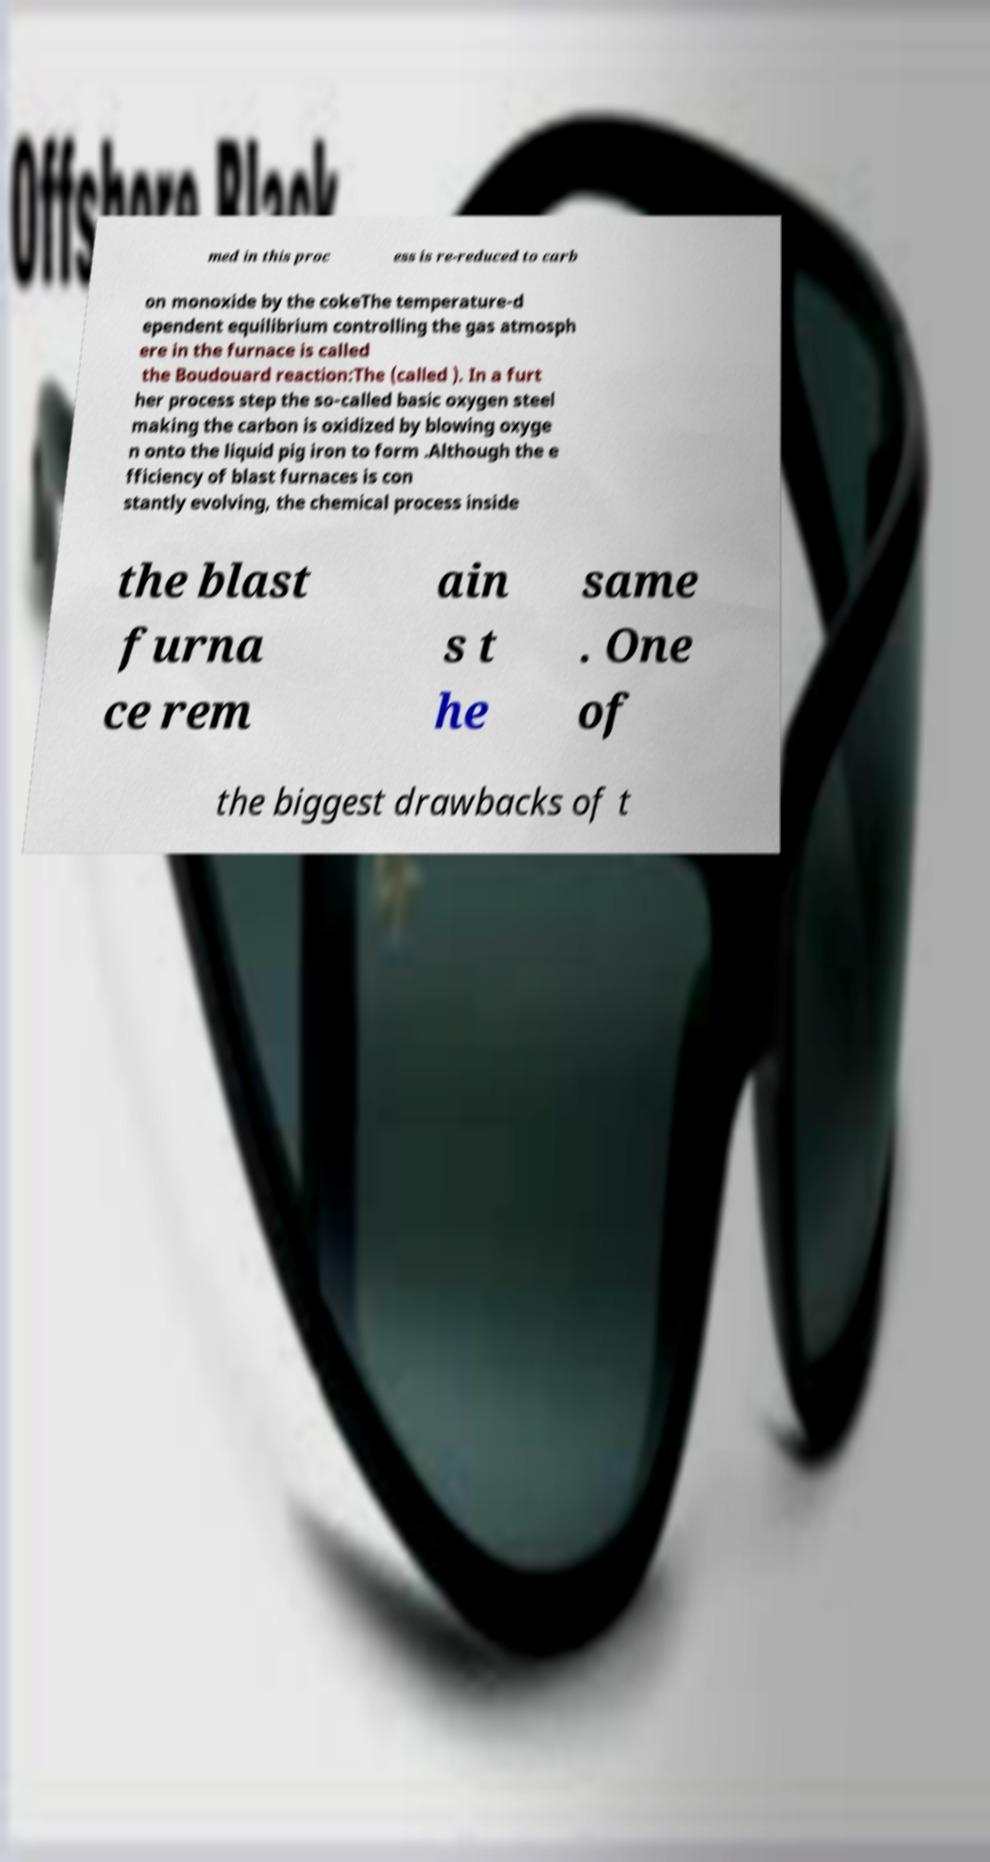Please identify and transcribe the text found in this image. med in this proc ess is re-reduced to carb on monoxide by the cokeThe temperature-d ependent equilibrium controlling the gas atmosph ere in the furnace is called the Boudouard reaction:The (called ). In a furt her process step the so-called basic oxygen steel making the carbon is oxidized by blowing oxyge n onto the liquid pig iron to form .Although the e fficiency of blast furnaces is con stantly evolving, the chemical process inside the blast furna ce rem ain s t he same . One of the biggest drawbacks of t 